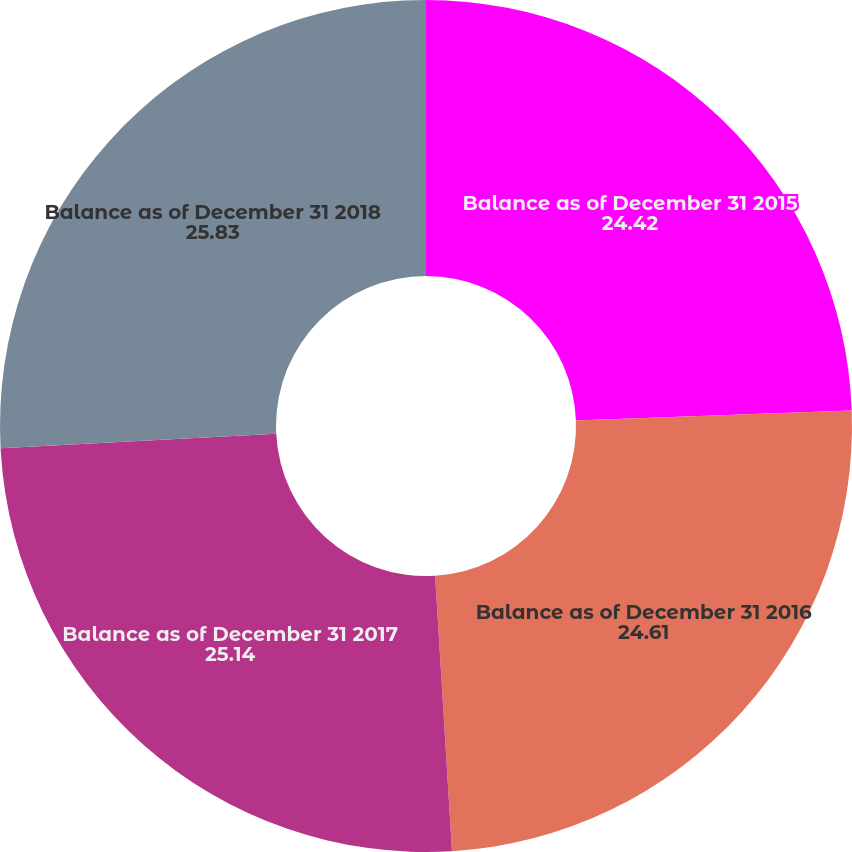<chart> <loc_0><loc_0><loc_500><loc_500><pie_chart><fcel>Balance as of December 31 2015<fcel>Balance as of December 31 2016<fcel>Balance as of December 31 2017<fcel>Balance as of December 31 2018<nl><fcel>24.42%<fcel>24.61%<fcel>25.14%<fcel>25.83%<nl></chart> 